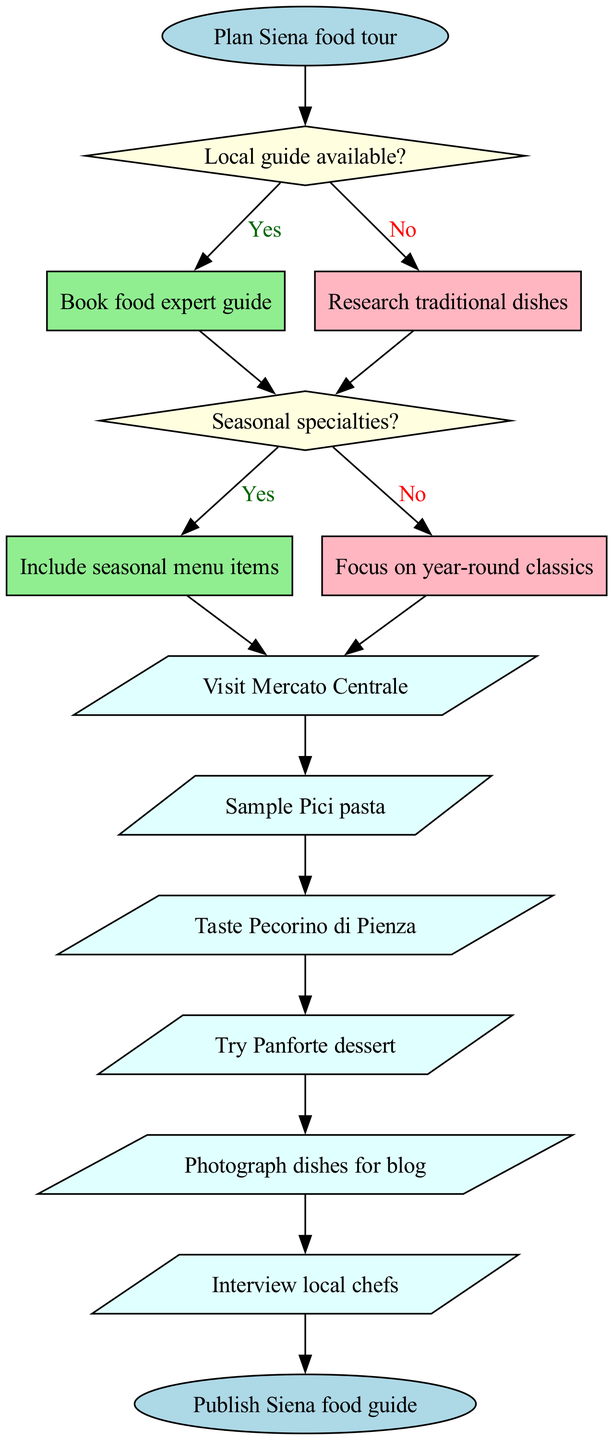What is the starting point of the flowchart? The starting point of the flowchart is labeled as "Plan Siena food tour," which indicates where the process begins.
Answer: Plan Siena food tour How many decision nodes are present in the diagram? The diagram contains two decision nodes: the first one asks about the availability of a local guide, and the second asks about seasonal specialties.
Answer: 2 What action follows if the answer to "Local guide available?" is yes? If the answer to "Local guide available?" is yes, the next action taken is to "Book food expert guide." This follows directly from the yes branch of the first decision node.
Answer: Book food expert guide If there are no seasonal specialties, which action is prioritized? If there are no seasonal specialties, the focus will be on "year-round classics," which comes directly from the no branch of the second decision node.
Answer: Focus on year-round classics What action is linked to the last action node before reaching the end? The last action linked before reaching the end node in the diagram is "Interview local chefs," which is followed by the final end point.
Answer: Interview local chefs What is the final step of the flowchart? The final step or end node of the flowchart is stated as "Publish Siena food guide," indicating the completion of the process.
Answer: Publish Siena food guide What happens if there is no local guide available? If there is no local guide available, the process branches to "Research traditional dishes," which is the outcome of the no response from the first decision node.
Answer: Research traditional dishes If seasonal specialties are included, what type of menu items are added? If seasonal specialties are confirmed, the flowchart indicates that "Include seasonal menu items" will be the action taken, as derived from the yes branch of the second decision node.
Answer: Include seasonal menu items 